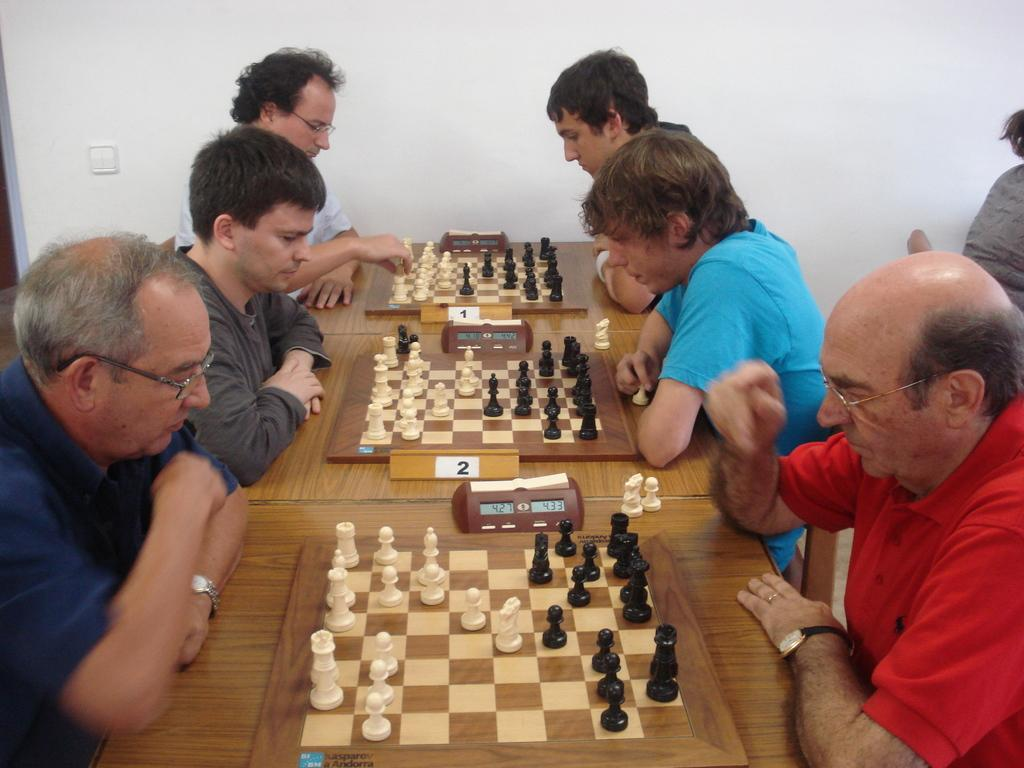What is located in the center of the image? There are tables in the center of the image. What is placed on the tables? Chess boards are placed on the tables. What is on the chess boards? Chess pieces are present on the chess boards. Who is near the tables? There are people sitting near the tables. What can be seen in the background of the image? There is a wall in the background of the image. What type of silk fabric is draped over the chess boards in the image? There is no silk fabric present on the chess boards in the image; they are simply wooden boards with chess pieces on them. What kind of breakfast is being served on the tables in the image? There is no breakfast present in the image; it features tables with chess boards and people playing chess. 